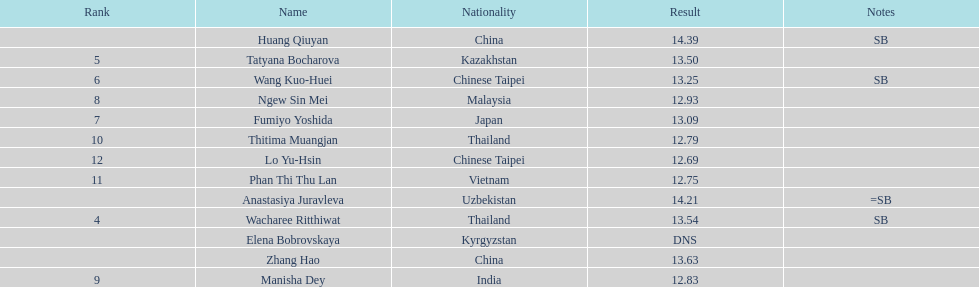How many people were ranked? 12. 